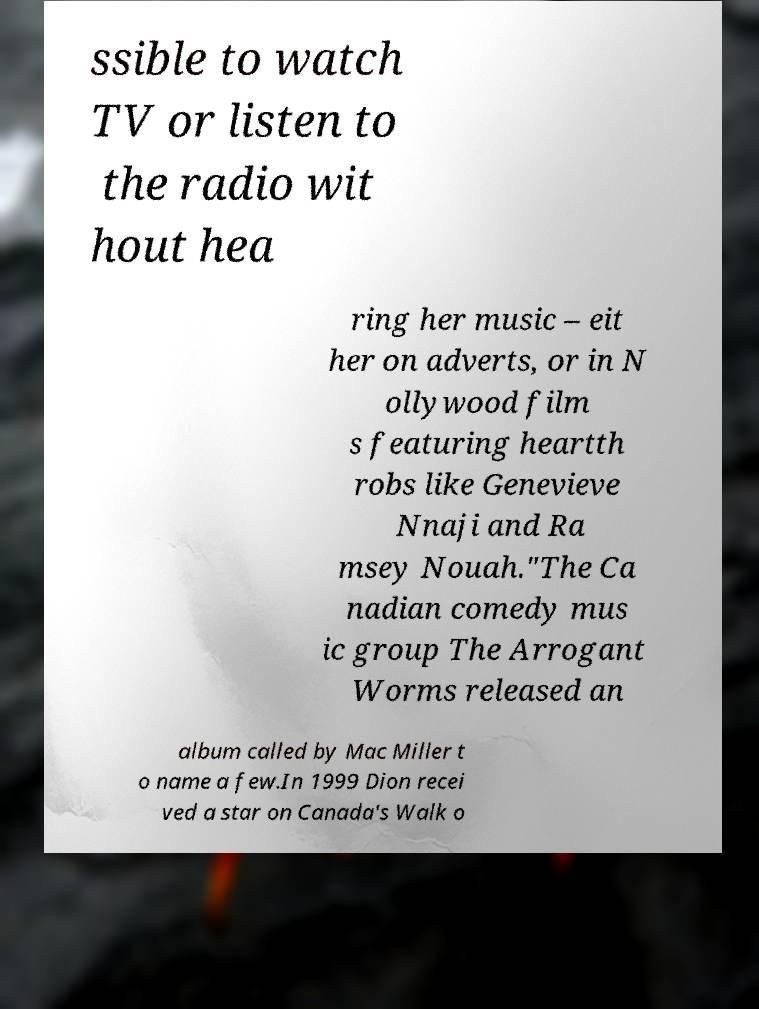Can you read and provide the text displayed in the image?This photo seems to have some interesting text. Can you extract and type it out for me? ssible to watch TV or listen to the radio wit hout hea ring her music – eit her on adverts, or in N ollywood film s featuring heartth robs like Genevieve Nnaji and Ra msey Nouah."The Ca nadian comedy mus ic group The Arrogant Worms released an album called by Mac Miller t o name a few.In 1999 Dion recei ved a star on Canada's Walk o 